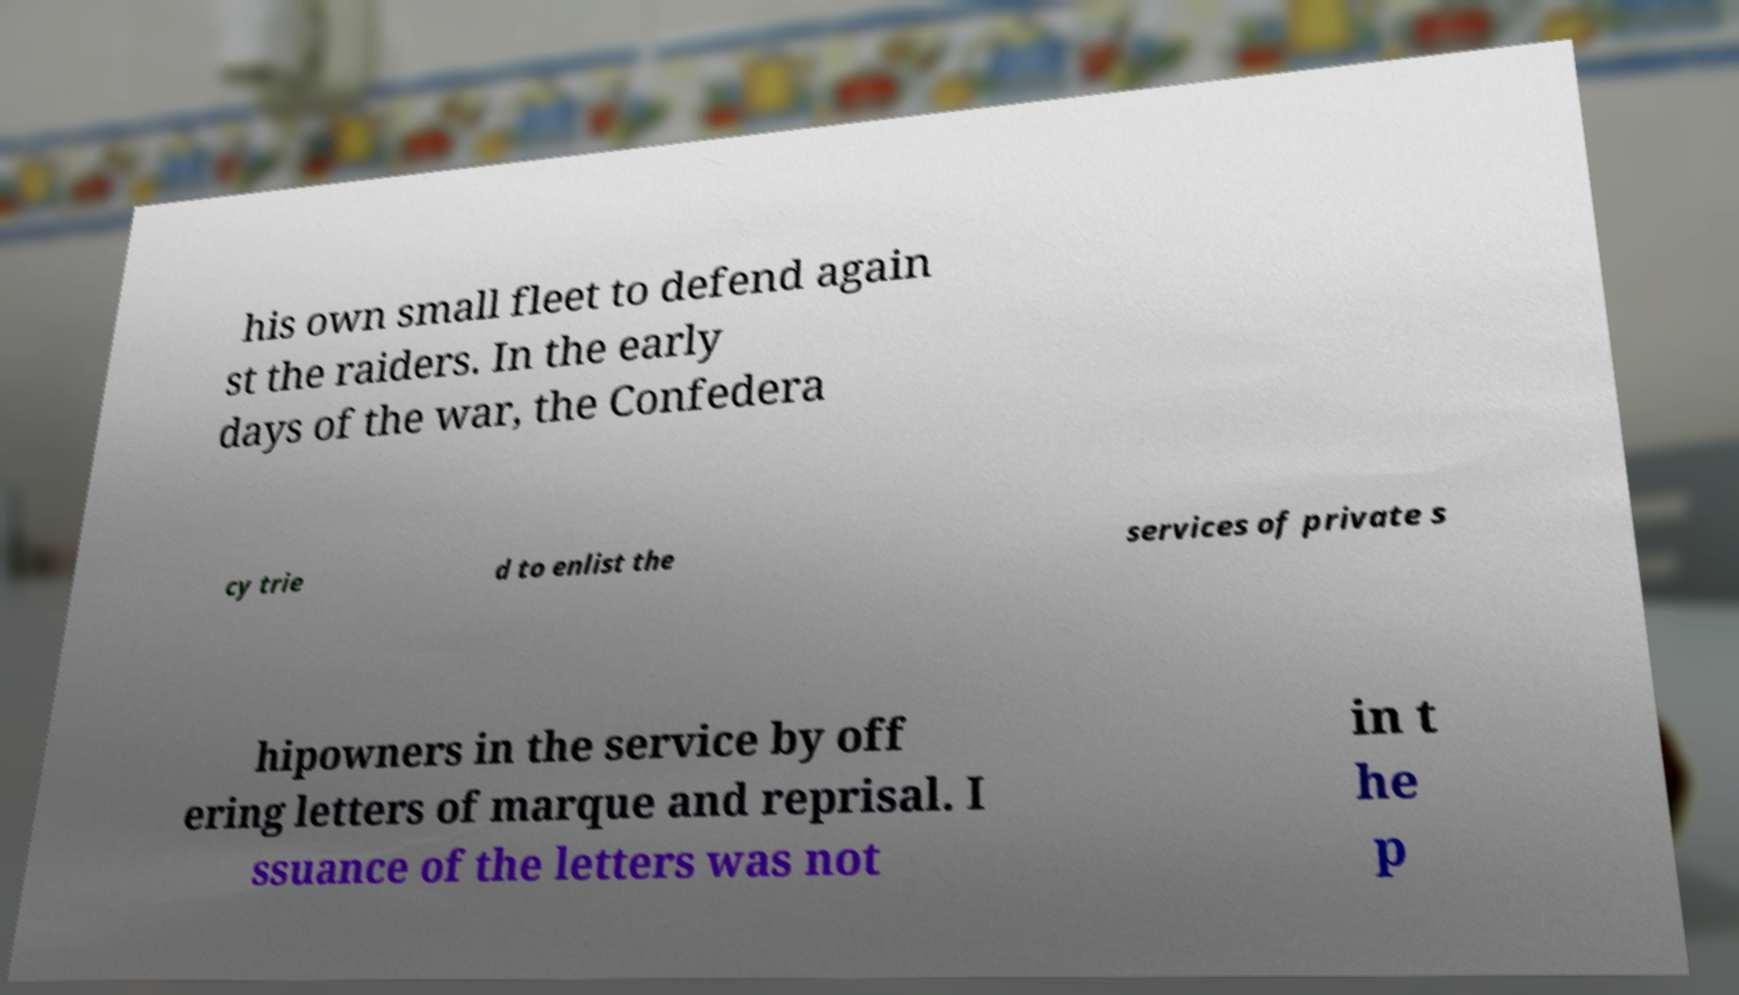Please read and relay the text visible in this image. What does it say? his own small fleet to defend again st the raiders. In the early days of the war, the Confedera cy trie d to enlist the services of private s hipowners in the service by off ering letters of marque and reprisal. I ssuance of the letters was not in t he p 